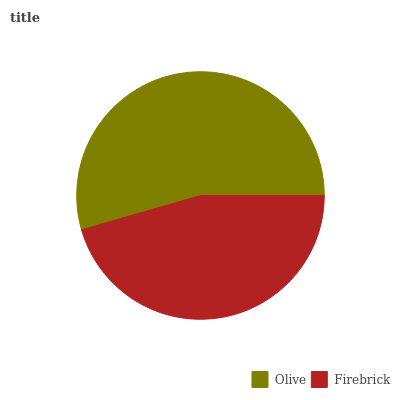Is Firebrick the minimum?
Answer yes or no. Yes. Is Olive the maximum?
Answer yes or no. Yes. Is Firebrick the maximum?
Answer yes or no. No. Is Olive greater than Firebrick?
Answer yes or no. Yes. Is Firebrick less than Olive?
Answer yes or no. Yes. Is Firebrick greater than Olive?
Answer yes or no. No. Is Olive less than Firebrick?
Answer yes or no. No. Is Olive the high median?
Answer yes or no. Yes. Is Firebrick the low median?
Answer yes or no. Yes. Is Firebrick the high median?
Answer yes or no. No. Is Olive the low median?
Answer yes or no. No. 